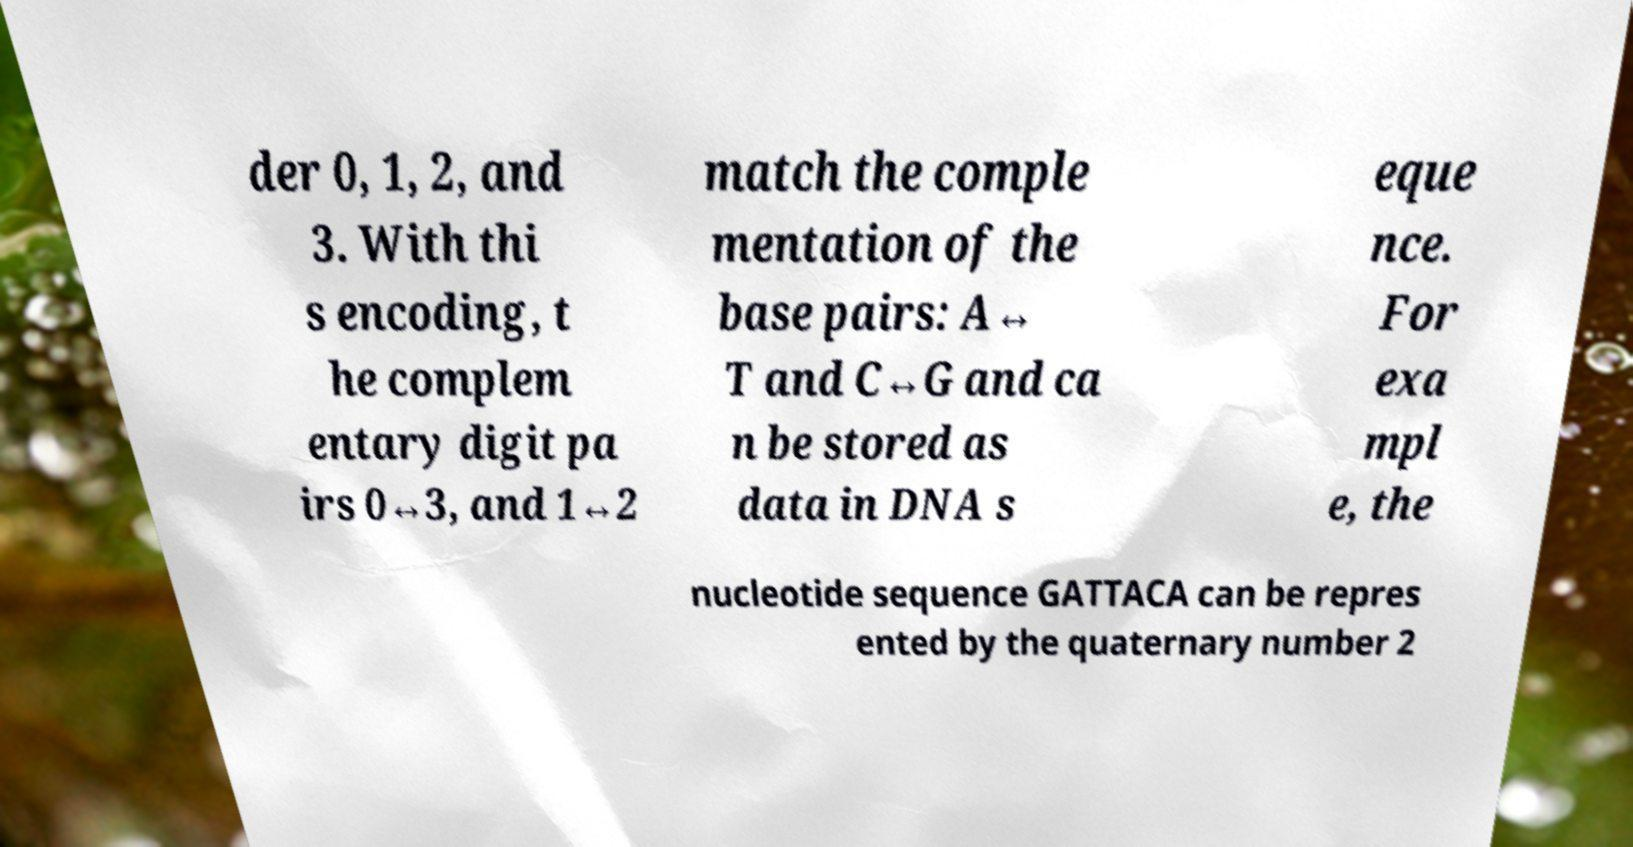Please read and relay the text visible in this image. What does it say? der 0, 1, 2, and 3. With thi s encoding, t he complem entary digit pa irs 0↔3, and 1↔2 match the comple mentation of the base pairs: A↔ T and C↔G and ca n be stored as data in DNA s eque nce. For exa mpl e, the nucleotide sequence GATTACA can be repres ented by the quaternary number 2 